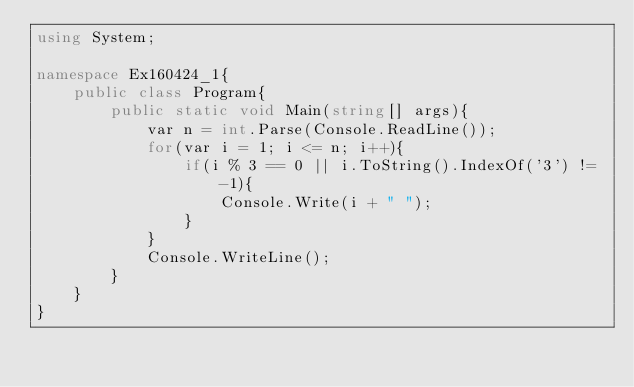Convert code to text. <code><loc_0><loc_0><loc_500><loc_500><_C#_>using System;

namespace Ex160424_1{
    public class Program{
        public static void Main(string[] args){
            var n = int.Parse(Console.ReadLine());
            for(var i = 1; i <= n; i++){
                if(i % 3 == 0 || i.ToString().IndexOf('3') != -1){
                    Console.Write(i + " ");
                }
            }
            Console.WriteLine();
        }
    }
}</code> 